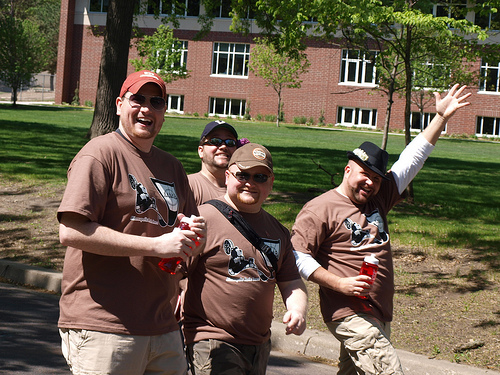<image>
Can you confirm if the hat is on the man? No. The hat is not positioned on the man. They may be near each other, but the hat is not supported by or resting on top of the man. Is there a man under the black hat? No. The man is not positioned under the black hat. The vertical relationship between these objects is different. 